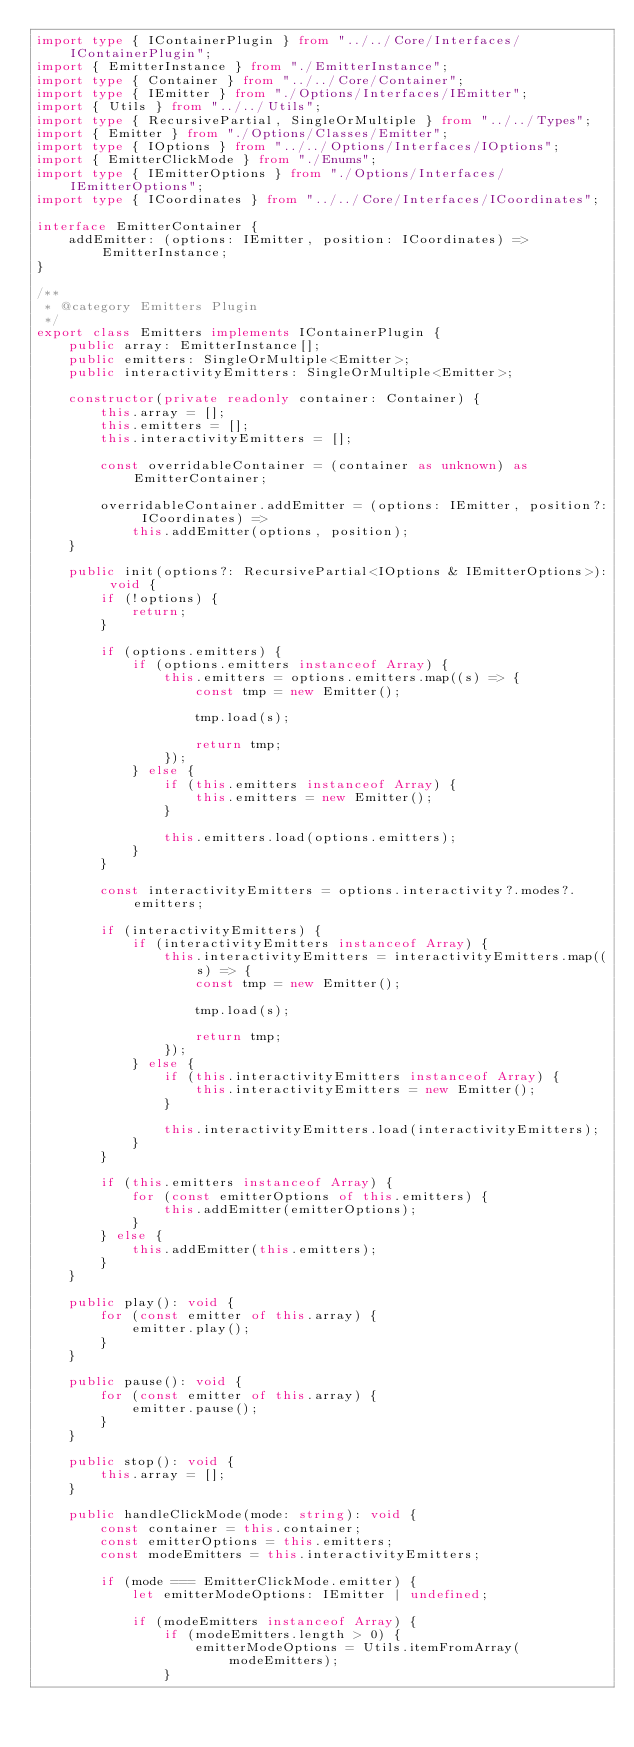Convert code to text. <code><loc_0><loc_0><loc_500><loc_500><_TypeScript_>import type { IContainerPlugin } from "../../Core/Interfaces/IContainerPlugin";
import { EmitterInstance } from "./EmitterInstance";
import type { Container } from "../../Core/Container";
import type { IEmitter } from "./Options/Interfaces/IEmitter";
import { Utils } from "../../Utils";
import type { RecursivePartial, SingleOrMultiple } from "../../Types";
import { Emitter } from "./Options/Classes/Emitter";
import type { IOptions } from "../../Options/Interfaces/IOptions";
import { EmitterClickMode } from "./Enums";
import type { IEmitterOptions } from "./Options/Interfaces/IEmitterOptions";
import type { ICoordinates } from "../../Core/Interfaces/ICoordinates";

interface EmitterContainer {
    addEmitter: (options: IEmitter, position: ICoordinates) => EmitterInstance;
}

/**
 * @category Emitters Plugin
 */
export class Emitters implements IContainerPlugin {
    public array: EmitterInstance[];
    public emitters: SingleOrMultiple<Emitter>;
    public interactivityEmitters: SingleOrMultiple<Emitter>;

    constructor(private readonly container: Container) {
        this.array = [];
        this.emitters = [];
        this.interactivityEmitters = [];

        const overridableContainer = (container as unknown) as EmitterContainer;

        overridableContainer.addEmitter = (options: IEmitter, position?: ICoordinates) =>
            this.addEmitter(options, position);
    }

    public init(options?: RecursivePartial<IOptions & IEmitterOptions>): void {
        if (!options) {
            return;
        }

        if (options.emitters) {
            if (options.emitters instanceof Array) {
                this.emitters = options.emitters.map((s) => {
                    const tmp = new Emitter();

                    tmp.load(s);

                    return tmp;
                });
            } else {
                if (this.emitters instanceof Array) {
                    this.emitters = new Emitter();
                }

                this.emitters.load(options.emitters);
            }
        }

        const interactivityEmitters = options.interactivity?.modes?.emitters;

        if (interactivityEmitters) {
            if (interactivityEmitters instanceof Array) {
                this.interactivityEmitters = interactivityEmitters.map((s) => {
                    const tmp = new Emitter();

                    tmp.load(s);

                    return tmp;
                });
            } else {
                if (this.interactivityEmitters instanceof Array) {
                    this.interactivityEmitters = new Emitter();
                }

                this.interactivityEmitters.load(interactivityEmitters);
            }
        }

        if (this.emitters instanceof Array) {
            for (const emitterOptions of this.emitters) {
                this.addEmitter(emitterOptions);
            }
        } else {
            this.addEmitter(this.emitters);
        }
    }

    public play(): void {
        for (const emitter of this.array) {
            emitter.play();
        }
    }

    public pause(): void {
        for (const emitter of this.array) {
            emitter.pause();
        }
    }

    public stop(): void {
        this.array = [];
    }

    public handleClickMode(mode: string): void {
        const container = this.container;
        const emitterOptions = this.emitters;
        const modeEmitters = this.interactivityEmitters;

        if (mode === EmitterClickMode.emitter) {
            let emitterModeOptions: IEmitter | undefined;

            if (modeEmitters instanceof Array) {
                if (modeEmitters.length > 0) {
                    emitterModeOptions = Utils.itemFromArray(modeEmitters);
                }</code> 